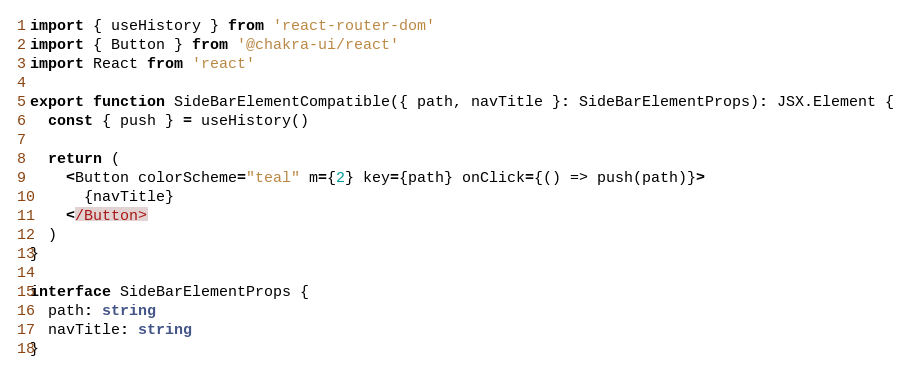Convert code to text. <code><loc_0><loc_0><loc_500><loc_500><_TypeScript_>import { useHistory } from 'react-router-dom'
import { Button } from '@chakra-ui/react'
import React from 'react'

export function SideBarElementCompatible({ path, navTitle }: SideBarElementProps): JSX.Element {
  const { push } = useHistory()

  return (
    <Button colorScheme="teal" m={2} key={path} onClick={() => push(path)}>
      {navTitle}
    </Button>
  )
}

interface SideBarElementProps {
  path: string
  navTitle: string
}
</code> 